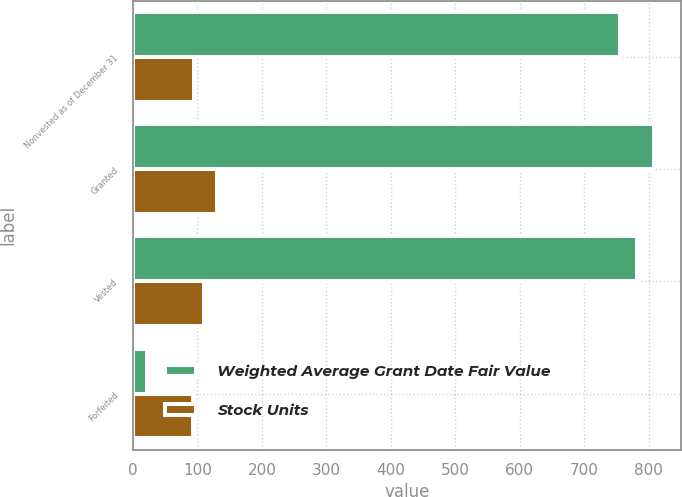<chart> <loc_0><loc_0><loc_500><loc_500><stacked_bar_chart><ecel><fcel>Nonvested as of December 31<fcel>Granted<fcel>Vested<fcel>Forfeited<nl><fcel>Weighted Average Grant Date Fair Value<fcel>756<fcel>809<fcel>782<fcel>22<nl><fcel>Stock Units<fcel>94.07<fcel>130.96<fcel>110.37<fcel>93.13<nl></chart> 